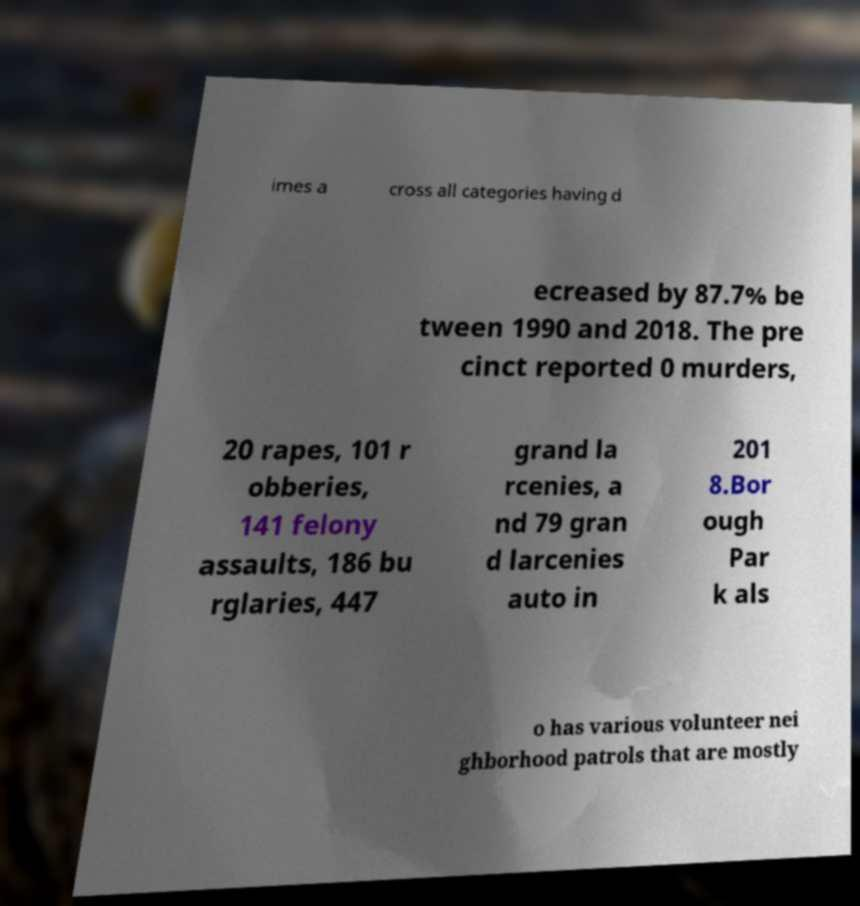Could you assist in decoding the text presented in this image and type it out clearly? imes a cross all categories having d ecreased by 87.7% be tween 1990 and 2018. The pre cinct reported 0 murders, 20 rapes, 101 r obberies, 141 felony assaults, 186 bu rglaries, 447 grand la rcenies, a nd 79 gran d larcenies auto in 201 8.Bor ough Par k als o has various volunteer nei ghborhood patrols that are mostly 